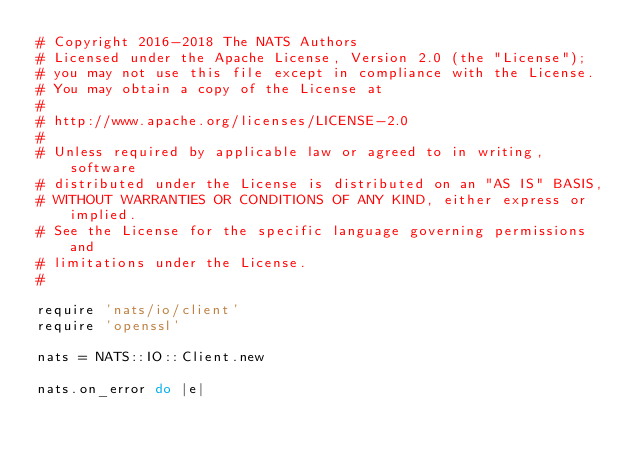Convert code to text. <code><loc_0><loc_0><loc_500><loc_500><_Ruby_># Copyright 2016-2018 The NATS Authors
# Licensed under the Apache License, Version 2.0 (the "License");
# you may not use this file except in compliance with the License.
# You may obtain a copy of the License at
#
# http://www.apache.org/licenses/LICENSE-2.0
#
# Unless required by applicable law or agreed to in writing, software
# distributed under the License is distributed on an "AS IS" BASIS,
# WITHOUT WARRANTIES OR CONDITIONS OF ANY KIND, either express or implied.
# See the License for the specific language governing permissions and
# limitations under the License.
#

require 'nats/io/client'
require 'openssl'

nats = NATS::IO::Client.new

nats.on_error do |e|</code> 